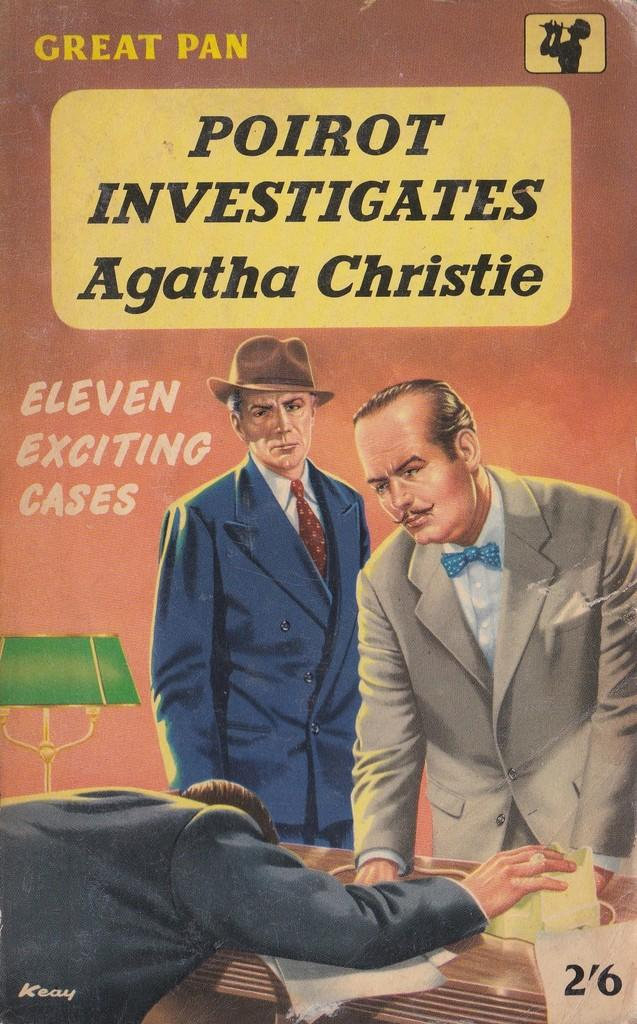What is featured on the poster in the image? The poster contains images of people. What type of lighting source is visible in the image? There is a lamp in the image. What can be found on the table in the image? There is a device on a table in the image. What is written or printed on the poster? Text is visible on the poster. Can you describe the girl with the flesh-colored tramp in the image? There is no girl or tramp present in the image; the poster contains images of people, and the text and lamp are also visible. 